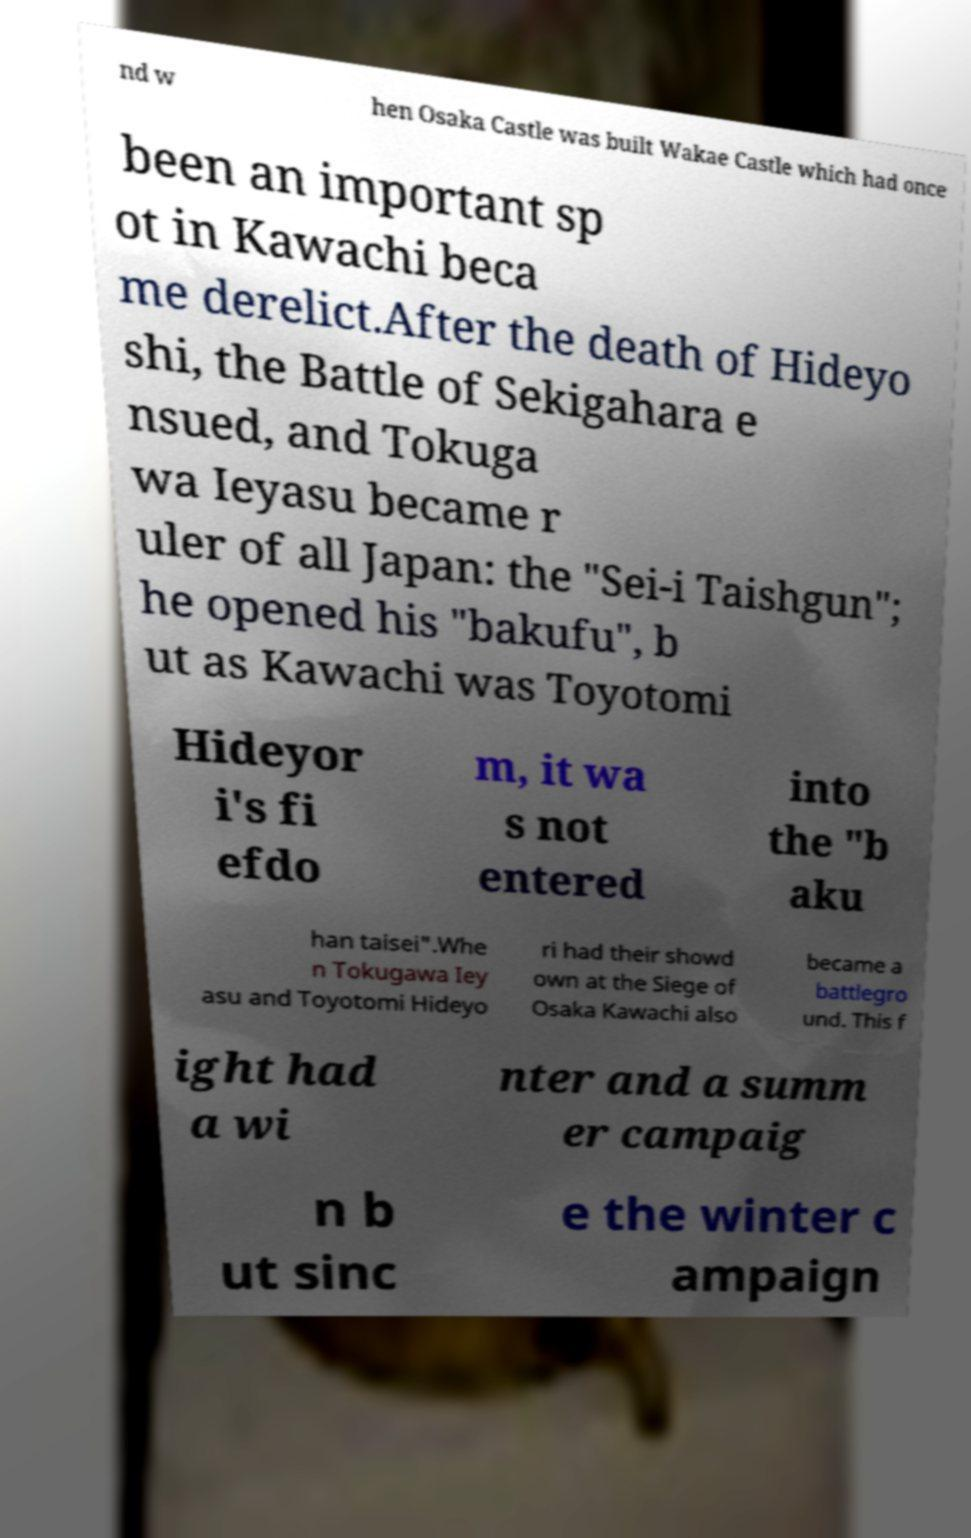Could you extract and type out the text from this image? nd w hen Osaka Castle was built Wakae Castle which had once been an important sp ot in Kawachi beca me derelict.After the death of Hideyo shi, the Battle of Sekigahara e nsued, and Tokuga wa Ieyasu became r uler of all Japan: the "Sei-i Taishgun"; he opened his "bakufu", b ut as Kawachi was Toyotomi Hideyor i's fi efdo m, it wa s not entered into the "b aku han taisei".Whe n Tokugawa Iey asu and Toyotomi Hideyo ri had their showd own at the Siege of Osaka Kawachi also became a battlegro und. This f ight had a wi nter and a summ er campaig n b ut sinc e the winter c ampaign 